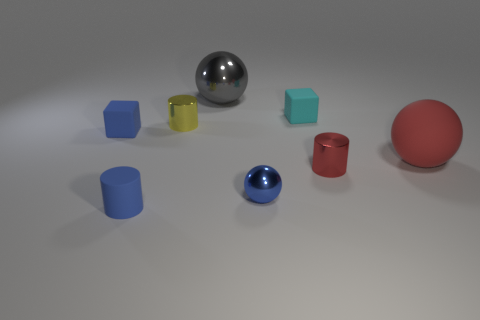Subtract all metal cylinders. How many cylinders are left? 1 Subtract 2 blocks. How many blocks are left? 0 Subtract all blue spheres. How many spheres are left? 2 Add 2 tiny red cylinders. How many objects exist? 10 Subtract all cylinders. How many objects are left? 5 Subtract all green spheres. How many blue cubes are left? 1 Subtract all small blue balls. Subtract all red matte balls. How many objects are left? 6 Add 8 tiny cyan matte blocks. How many tiny cyan matte blocks are left? 9 Add 7 cyan matte blocks. How many cyan matte blocks exist? 8 Subtract 1 gray spheres. How many objects are left? 7 